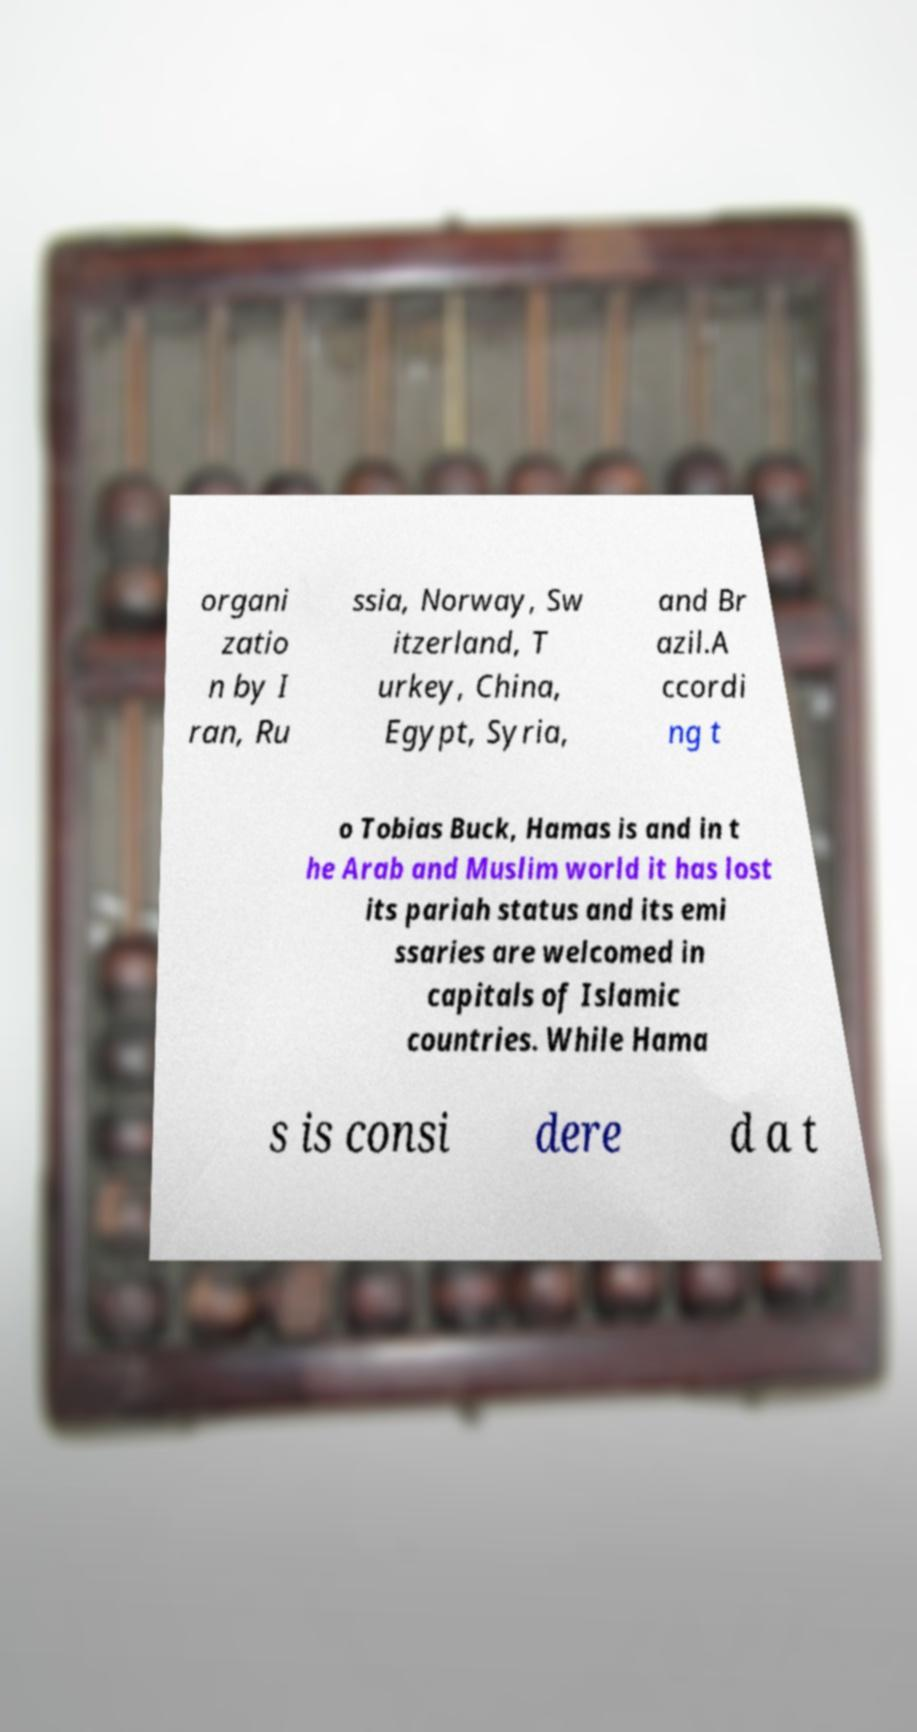I need the written content from this picture converted into text. Can you do that? organi zatio n by I ran, Ru ssia, Norway, Sw itzerland, T urkey, China, Egypt, Syria, and Br azil.A ccordi ng t o Tobias Buck, Hamas is and in t he Arab and Muslim world it has lost its pariah status and its emi ssaries are welcomed in capitals of Islamic countries. While Hama s is consi dere d a t 